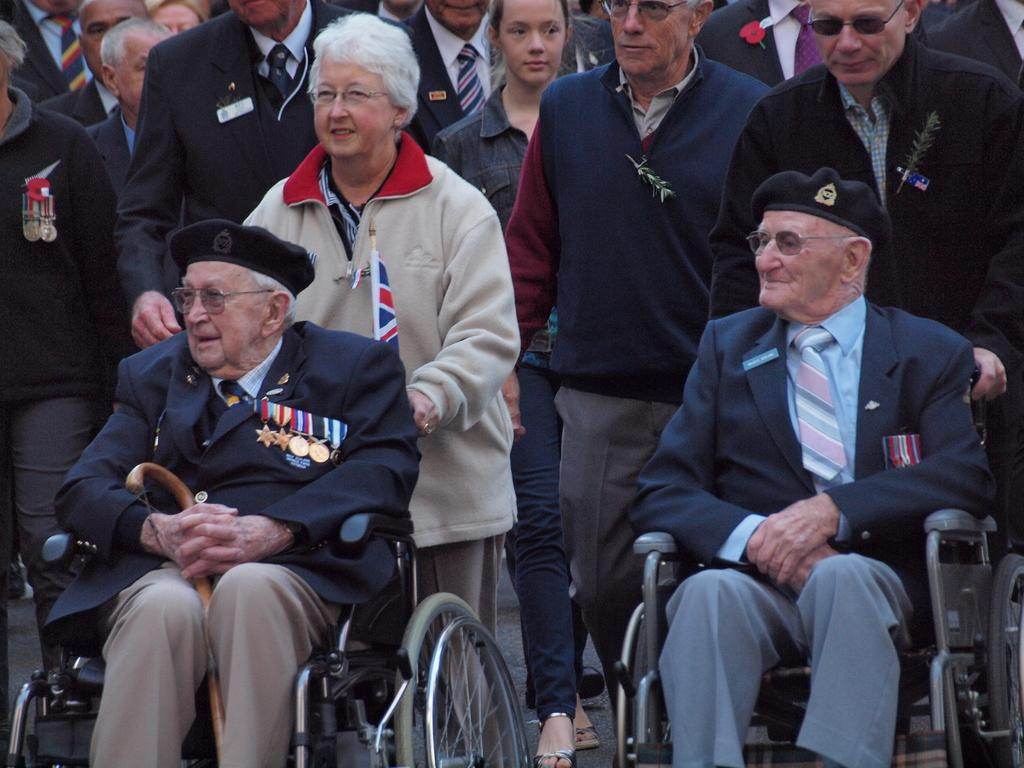What are the two old men in the image doing? The two old men are sitting in wheelchairs. What is the activity of the group of people in the image? There is a group of people standing. Can you identify any symbol or emblem in the image? Yes, there appears to be a flag in the image. What is the average income of the people in the image? There is no information about the income of the people in the image, so it cannot be determined. 